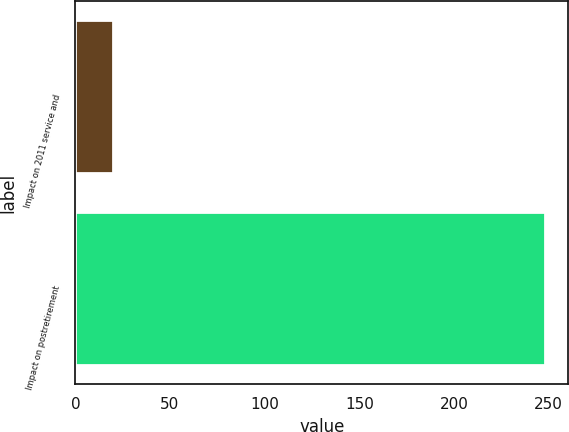Convert chart. <chart><loc_0><loc_0><loc_500><loc_500><bar_chart><fcel>Impact on 2011 service and<fcel>Impact on postretirement<nl><fcel>20<fcel>248<nl></chart> 